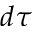Convert formula to latex. <formula><loc_0><loc_0><loc_500><loc_500>d \tau</formula> 